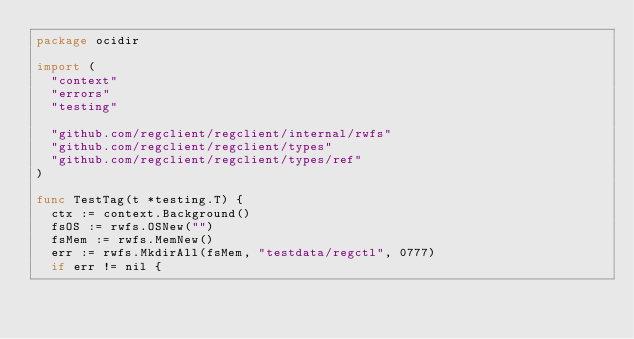<code> <loc_0><loc_0><loc_500><loc_500><_Go_>package ocidir

import (
	"context"
	"errors"
	"testing"

	"github.com/regclient/regclient/internal/rwfs"
	"github.com/regclient/regclient/types"
	"github.com/regclient/regclient/types/ref"
)

func TestTag(t *testing.T) {
	ctx := context.Background()
	fsOS := rwfs.OSNew("")
	fsMem := rwfs.MemNew()
	err := rwfs.MkdirAll(fsMem, "testdata/regctl", 0777)
	if err != nil {</code> 